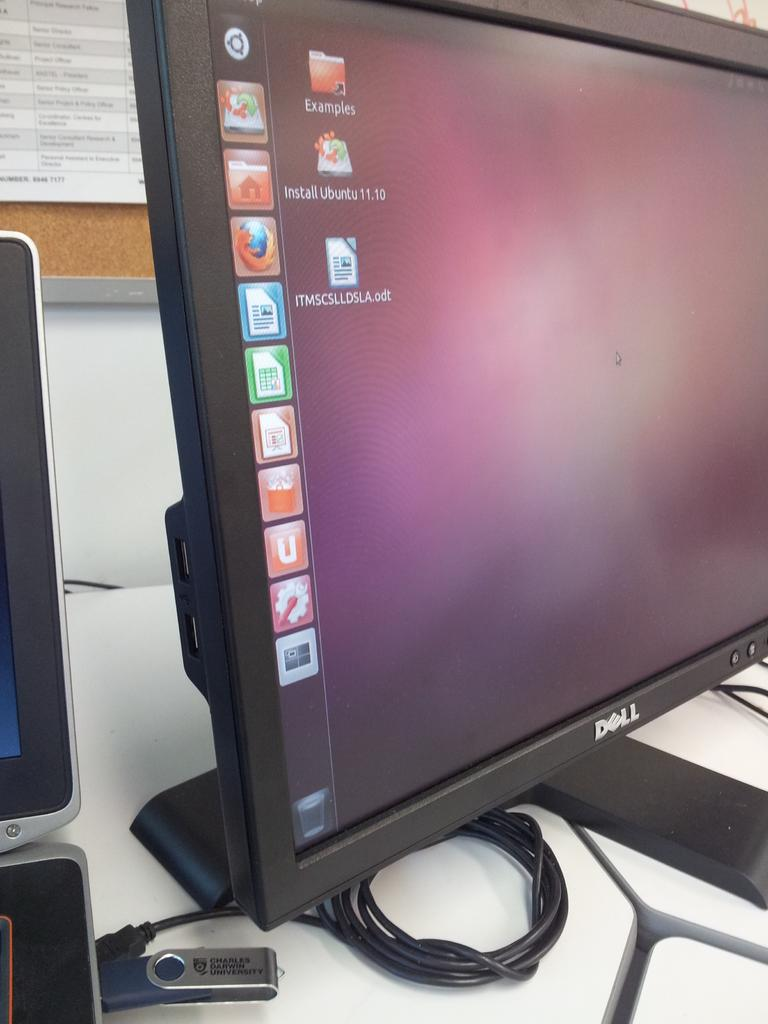<image>
Render a clear and concise summary of the photo. A short cut to a folder labeled Examples is displayed at the top of the monitor. 